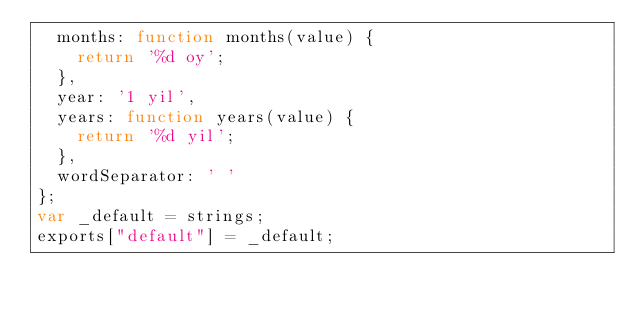Convert code to text. <code><loc_0><loc_0><loc_500><loc_500><_JavaScript_>  months: function months(value) {
    return '%d oy';
  },
  year: '1 yil',
  years: function years(value) {
    return '%d yil';
  },
  wordSeparator: ' '
};
var _default = strings;
exports["default"] = _default;</code> 